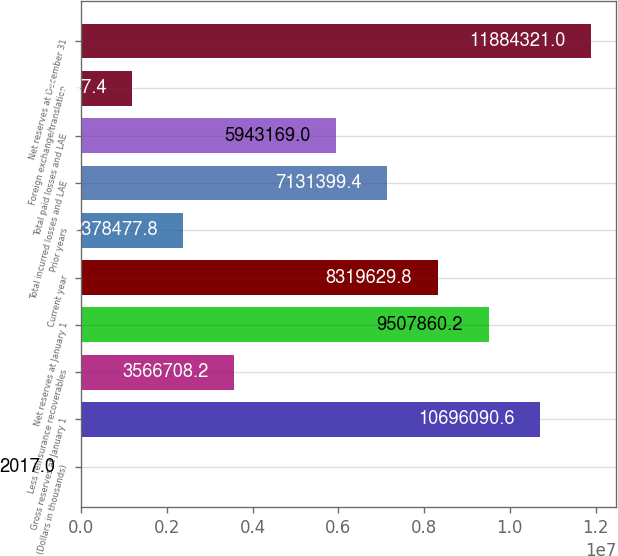Convert chart to OTSL. <chart><loc_0><loc_0><loc_500><loc_500><bar_chart><fcel>(Dollars in thousands)<fcel>Gross reserves at January 1<fcel>Less reinsurance recoverables<fcel>Net reserves at January 1<fcel>Current year<fcel>Prior years<fcel>Total incurred losses and LAE<fcel>Total paid losses and LAE<fcel>Foreign exchange/translation<fcel>Net reserves at December 31<nl><fcel>2017<fcel>1.06961e+07<fcel>3.56671e+06<fcel>9.50786e+06<fcel>8.31963e+06<fcel>2.37848e+06<fcel>7.1314e+06<fcel>5.94317e+06<fcel>1.19025e+06<fcel>1.18843e+07<nl></chart> 